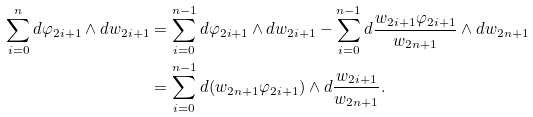<formula> <loc_0><loc_0><loc_500><loc_500>\sum _ { i = 0 } ^ { n } d \varphi _ { 2 i + 1 } \wedge d w _ { 2 i + 1 } & = \sum _ { i = 0 } ^ { n - 1 } d \varphi _ { 2 i + 1 } \wedge d w _ { 2 i + 1 } - \sum _ { i = 0 } ^ { n - 1 } d \frac { w _ { 2 i + 1 } \varphi _ { 2 i + 1 } } { w _ { 2 n + 1 } } \wedge d w _ { 2 n + 1 } \\ & = \sum _ { i = 0 } ^ { n - 1 } d ( w _ { 2 n + 1 } \varphi _ { 2 i + 1 } ) \wedge d \frac { w _ { 2 i + 1 } } { w _ { 2 n + 1 } } .</formula> 